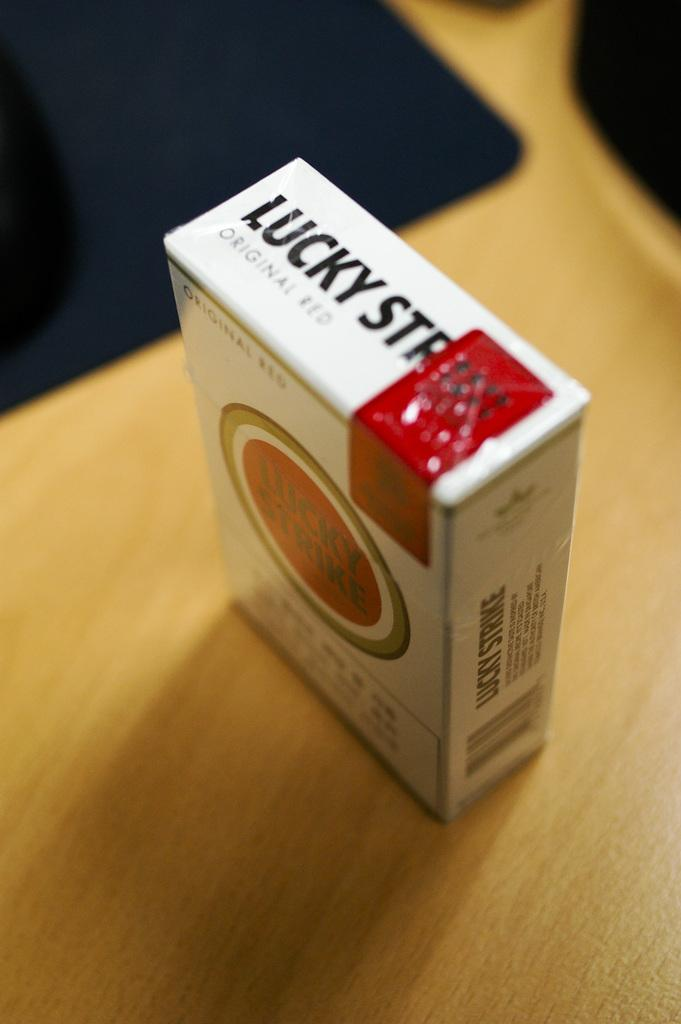Provide a one-sentence caption for the provided image. The pack of cigarette on the counter is a pack of Luck Strikes Original Red. 